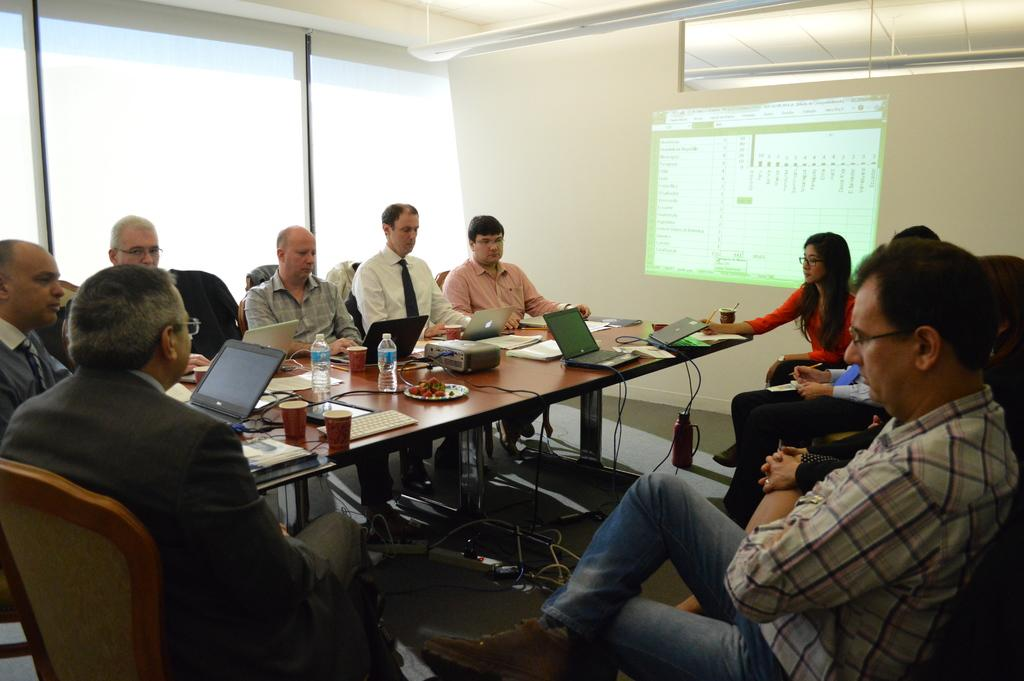How many people are in the image? There is a group of people in the image. What are the people doing in the image? The people are sitting on chairs. What is the arrangement of the chairs in the image? The chairs are around a table. What items can be seen on the table in the image? There are water bottles, food, a projector, a laptop, books, and cups on the table. What is visible in the background of the image? There is a screen visible in the background. What type of bag is being used to improve the acoustics in the image? There is no bag present in the image, and the acoustics are not mentioned or affected by any visible objects. 